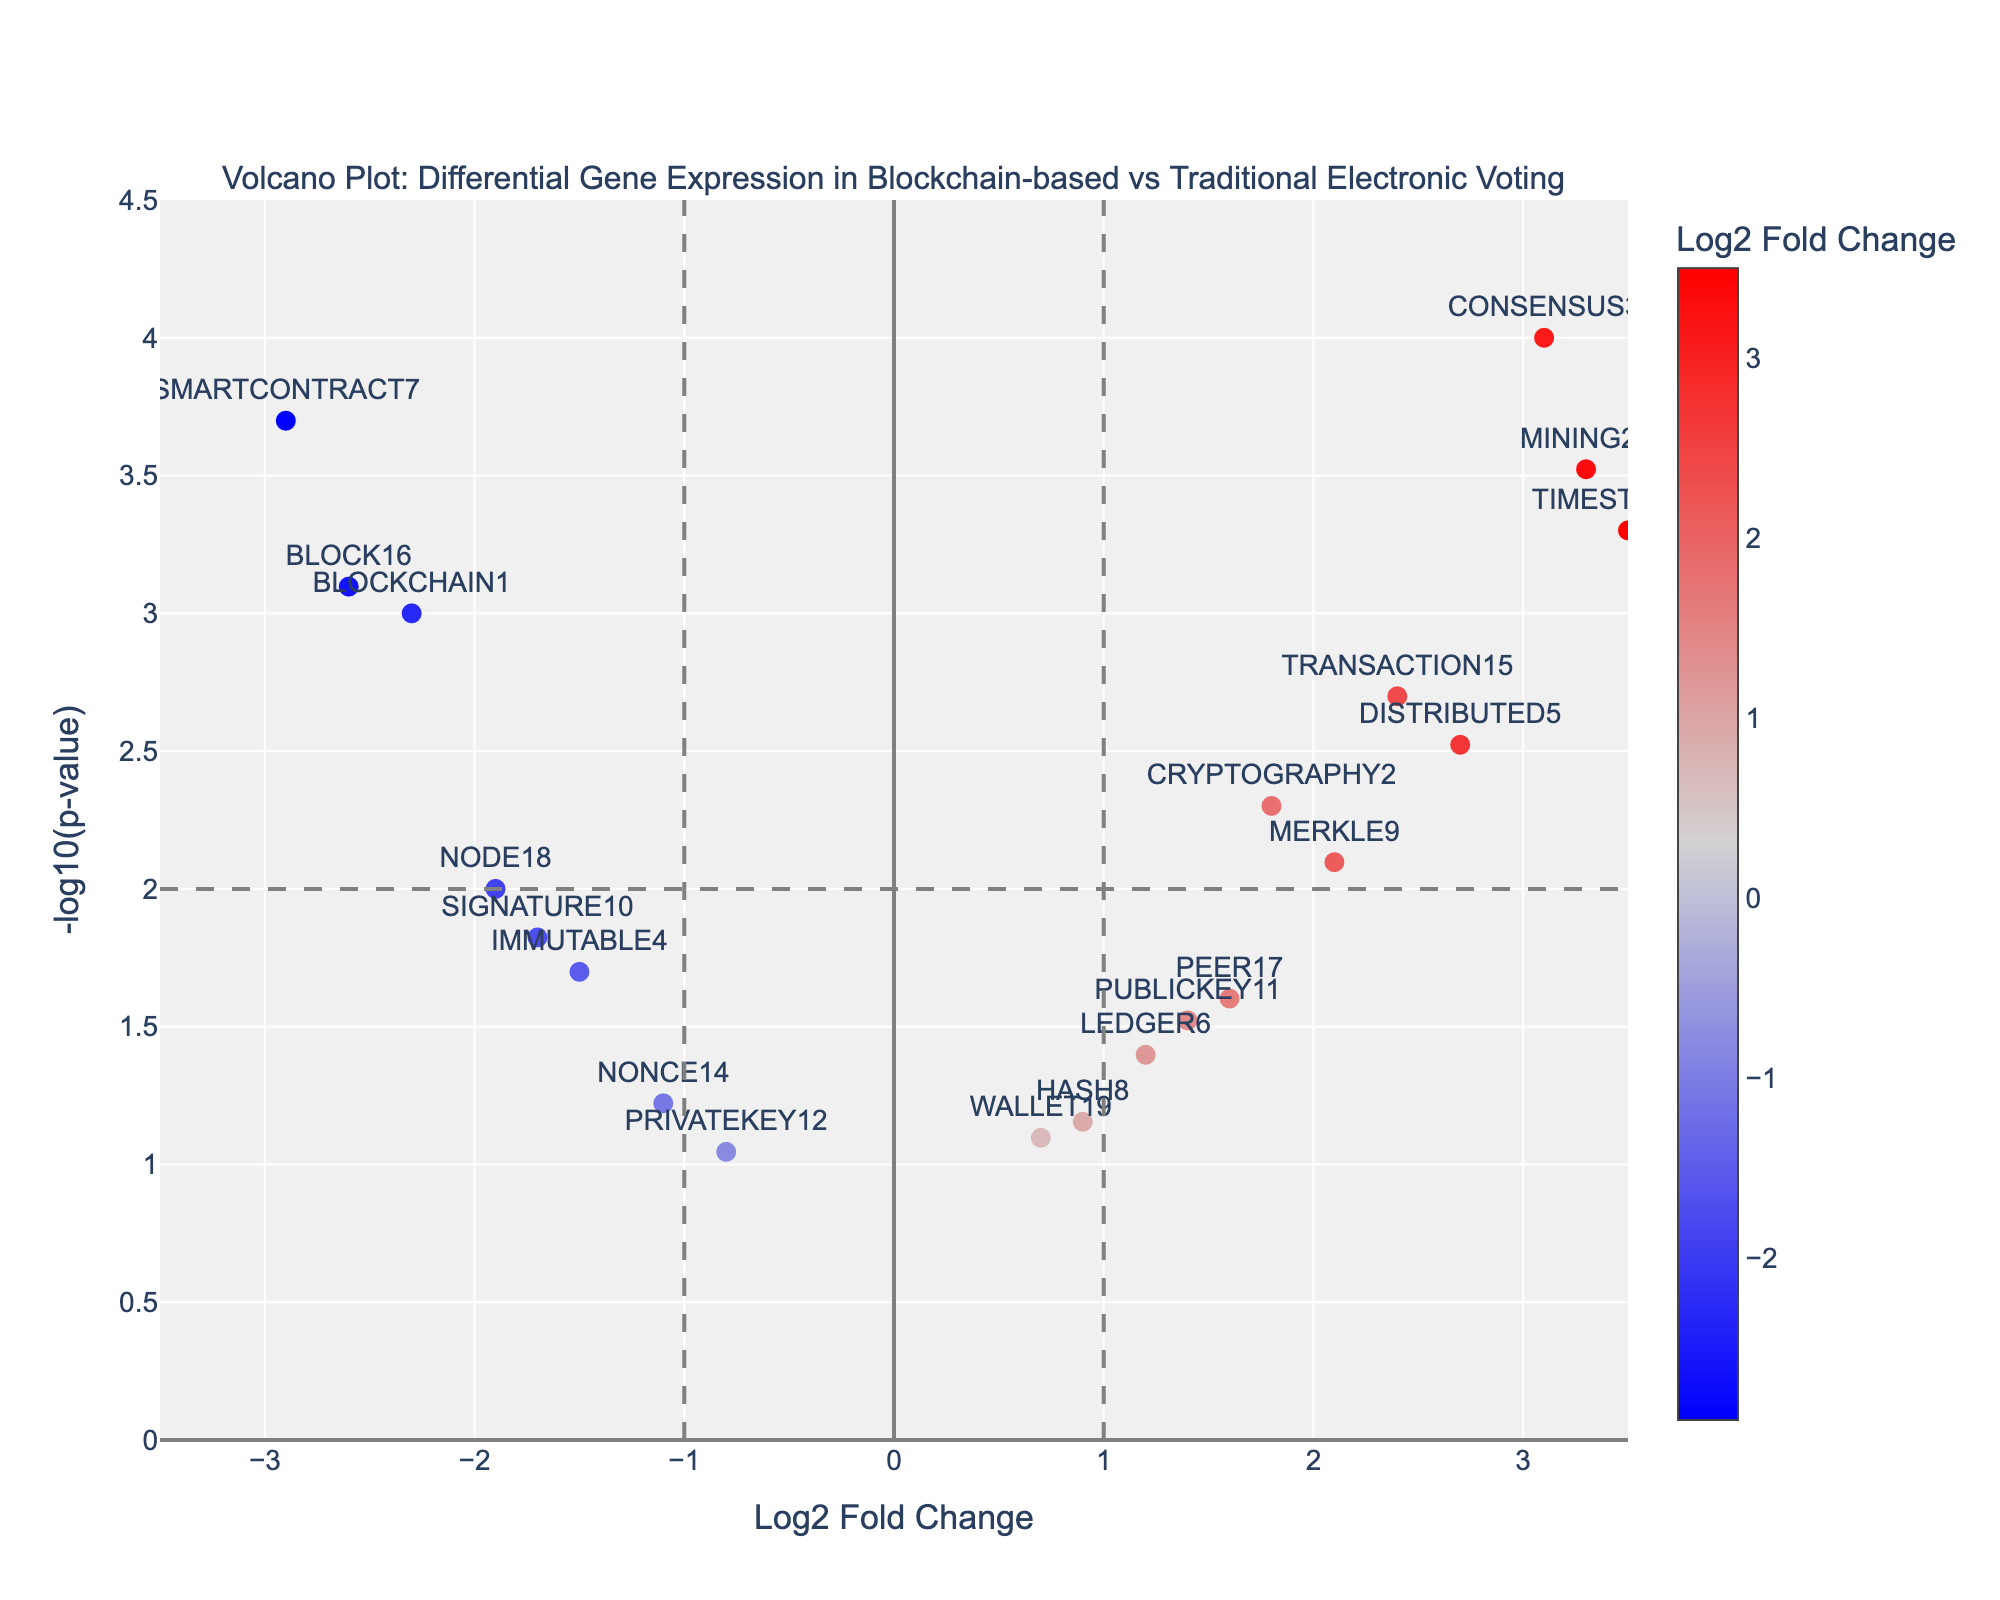What's the title of the plot? The title of the plot appears at the top and summarizes the content of the figure.
Answer: Volcano Plot: Differential Gene Expression in Blockchain-based vs Traditional Electronic Voting What do the axes represent in the plot? The x-axis represents Log2 Fold Change, and the y-axis represents -log10(p-value). These labels are found alongside the axes.
Answer: Log2 Fold Change on x-axis, -log10(p-value) on y-axis Which gene shows the highest -log10(p-value)? Locate the point with the highest y-value on the plot, which represents the highest -log10(p-value). The label next to this point indicates the gene.
Answer: CONSENSUS3 How many genes have a Log2 Fold Change greater than 2? Identify points with x-values greater than 2. Checking the labels on these points confirms the number of genes that meet the condition.
Answer: 3 genes (DISTRIBUTED5, MINING20, TIMESTAMP13) Which gene has the most negative Log2 Fold Change? Locate the leftmost point on the x-axis, indicating the most negative Log2 Fold Change. The label next to this point shows the gene's name.
Answer: SMARTCONTRACT7 What is the Log2 Fold Change and p-value of the gene BLOCK16? Find the point labeled BLOCK16 on the plot and use the hover text to confirm Log2 Fold Change and p-value values.
Answer: Log2 Fold Change: -2.6, p-value: 0.0008 Between the genes PUBLICKEY11 and PEER17, which one has a higher -log10(p-value)? Compare the y-values of points labeled PUBLICKEY11 and PEER17. The point higher on the y-axis has the higher -log10(p-value).
Answer: PEER17 What threshold for -log10(p-value) is marked by a horizontal line in the plot? Identify the value on the y-axis where the horizontal line is drawn, which indicates the threshold.
Answer: 2 How many genes have a p-value less than 0.01? A p-value less than 0.01 corresponds to a -log10(p-value) greater than 2. Count the points above the horizontal line at y=2.
Answer: 7 genes 